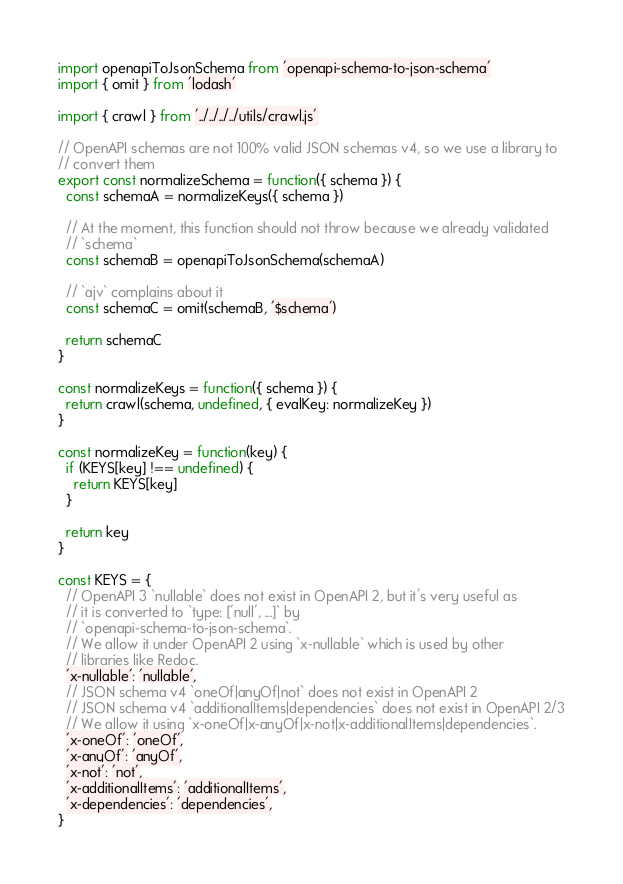Convert code to text. <code><loc_0><loc_0><loc_500><loc_500><_JavaScript_>import openapiToJsonSchema from 'openapi-schema-to-json-schema'
import { omit } from 'lodash'

import { crawl } from '../../../../utils/crawl.js'

// OpenAPI schemas are not 100% valid JSON schemas v4, so we use a library to
// convert them
export const normalizeSchema = function({ schema }) {
  const schemaA = normalizeKeys({ schema })

  // At the moment, this function should not throw because we already validated
  // `schema`
  const schemaB = openapiToJsonSchema(schemaA)

  // `ajv` complains about it
  const schemaC = omit(schemaB, '$schema')

  return schemaC
}

const normalizeKeys = function({ schema }) {
  return crawl(schema, undefined, { evalKey: normalizeKey })
}

const normalizeKey = function(key) {
  if (KEYS[key] !== undefined) {
    return KEYS[key]
  }

  return key
}

const KEYS = {
  // OpenAPI 3 `nullable` does not exist in OpenAPI 2, but it's very useful as
  // it is converted to `type: ['null', ...]` by
  // `openapi-schema-to-json-schema`.
  // We allow it under OpenAPI 2 using `x-nullable` which is used by other
  // libraries like Redoc.
  'x-nullable': 'nullable',
  // JSON schema v4 `oneOf|anyOf|not` does not exist in OpenAPI 2
  // JSON schema v4 `additionalItems|dependencies` does not exist in OpenAPI 2/3
  // We allow it using `x-oneOf|x-anyOf|x-not|x-additionalItems|dependencies`.
  'x-oneOf': 'oneOf',
  'x-anyOf': 'anyOf',
  'x-not': 'not',
  'x-additionalItems': 'additionalItems',
  'x-dependencies': 'dependencies',
}
</code> 